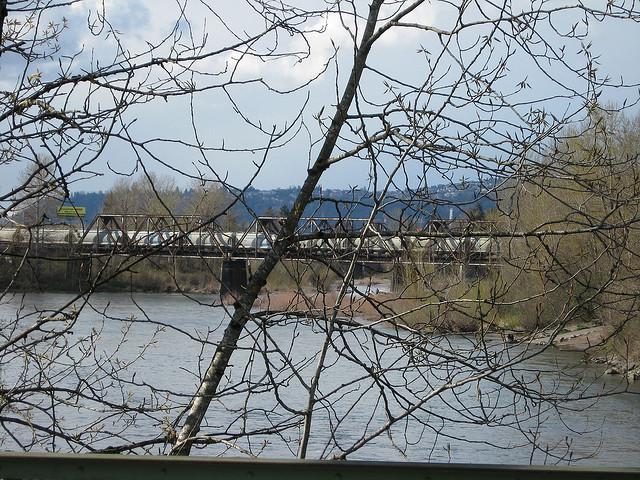What is the color of hydrate?
Quick response, please. Gray. What is on the bridge?
Be succinct. Train. Is the tree covering half the picture?
Quick response, please. Yes. Is it cold outside?
Quick response, please. Yes. What type of fencing is in the scene?
Short answer required. Metal. 